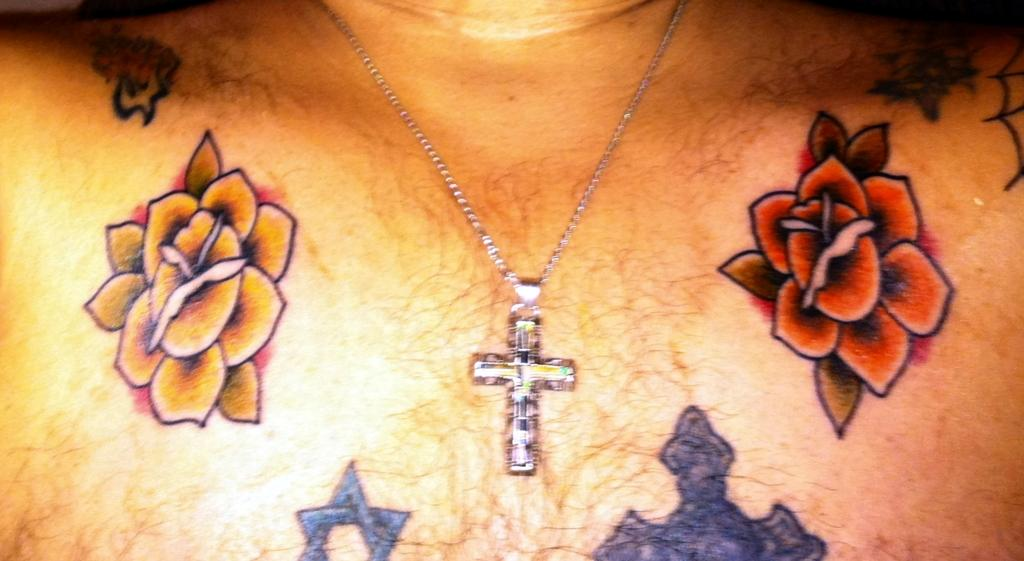What is depicted on the person's body in the image? There are paintings on a person's body in the image. What other object can be seen in the image? There is a chain with a locket in the image. What decision does the person make regarding the loaf in the image? There is no loaf present in the image, so it is not possible to determine any decisions made regarding a loaf. 